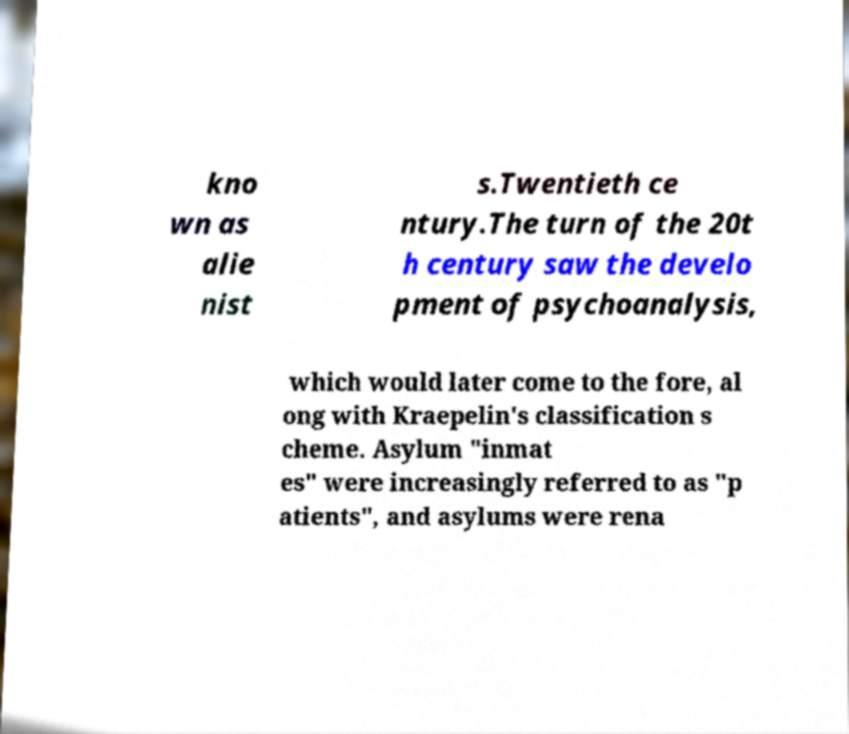For documentation purposes, I need the text within this image transcribed. Could you provide that? kno wn as alie nist s.Twentieth ce ntury.The turn of the 20t h century saw the develo pment of psychoanalysis, which would later come to the fore, al ong with Kraepelin's classification s cheme. Asylum "inmat es" were increasingly referred to as "p atients", and asylums were rena 